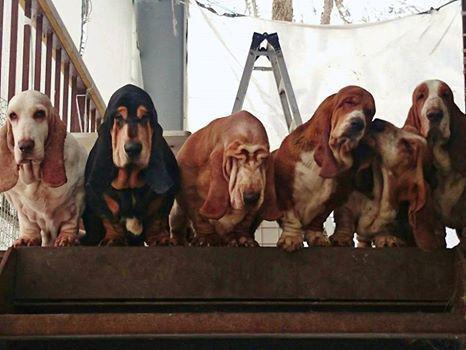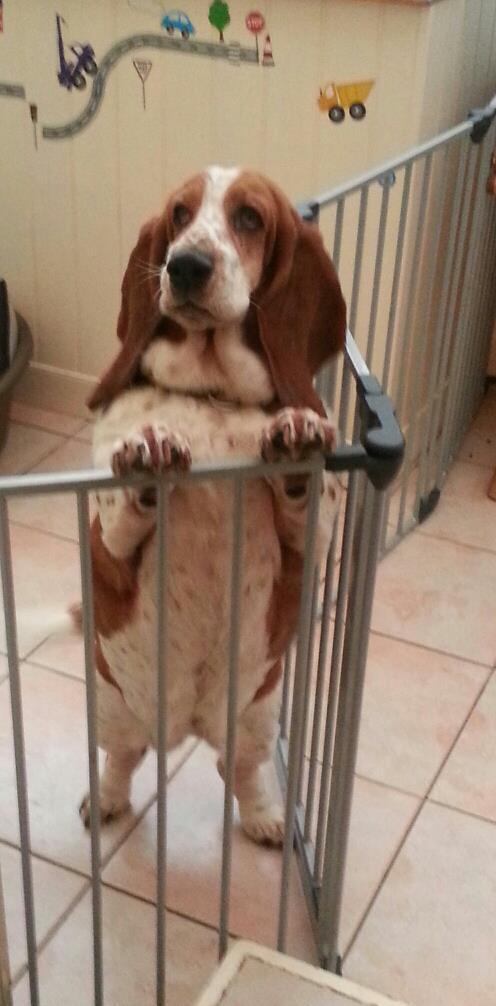The first image is the image on the left, the second image is the image on the right. Evaluate the accuracy of this statement regarding the images: "In one of the pictures a dog is standing on its hind legs.". Is it true? Answer yes or no. Yes. 